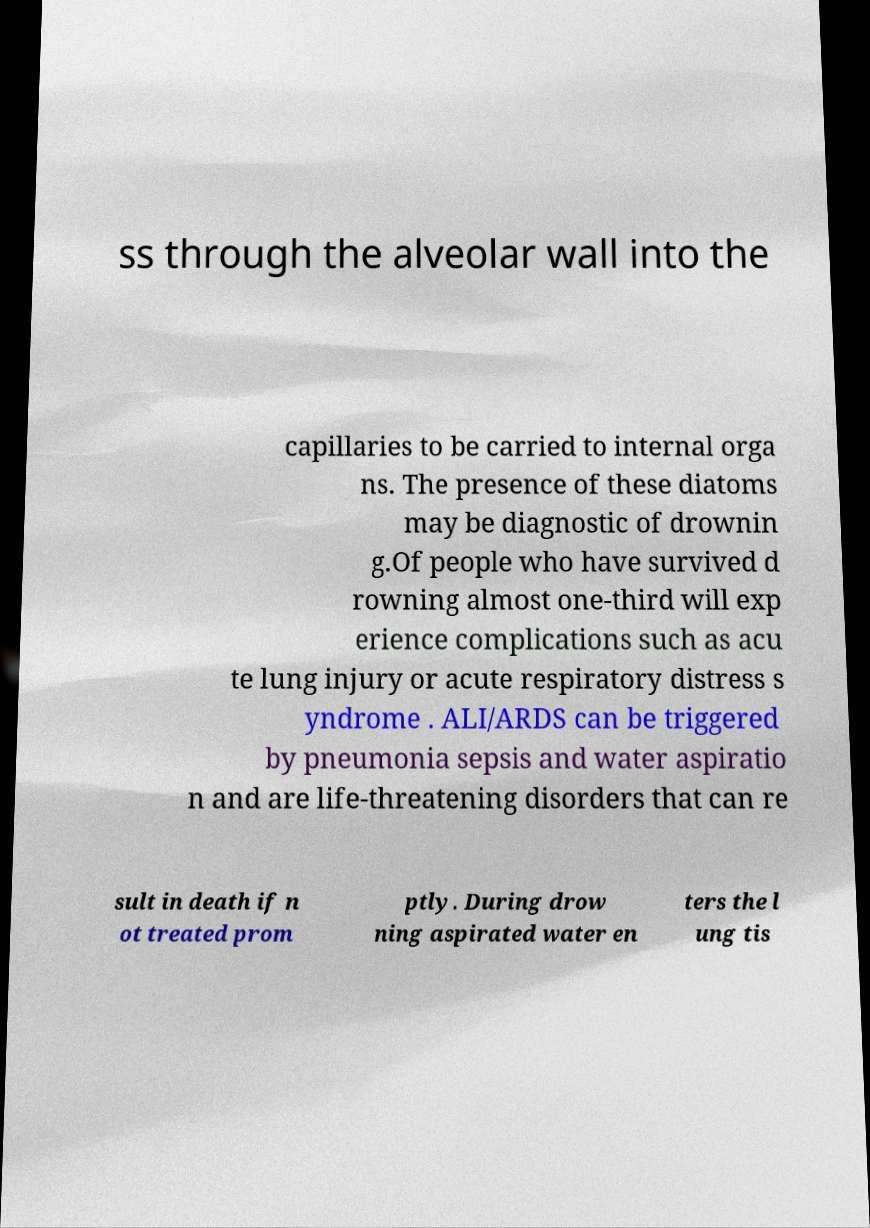There's text embedded in this image that I need extracted. Can you transcribe it verbatim? ss through the alveolar wall into the capillaries to be carried to internal orga ns. The presence of these diatoms may be diagnostic of drownin g.Of people who have survived d rowning almost one-third will exp erience complications such as acu te lung injury or acute respiratory distress s yndrome . ALI/ARDS can be triggered by pneumonia sepsis and water aspiratio n and are life-threatening disorders that can re sult in death if n ot treated prom ptly. During drow ning aspirated water en ters the l ung tis 